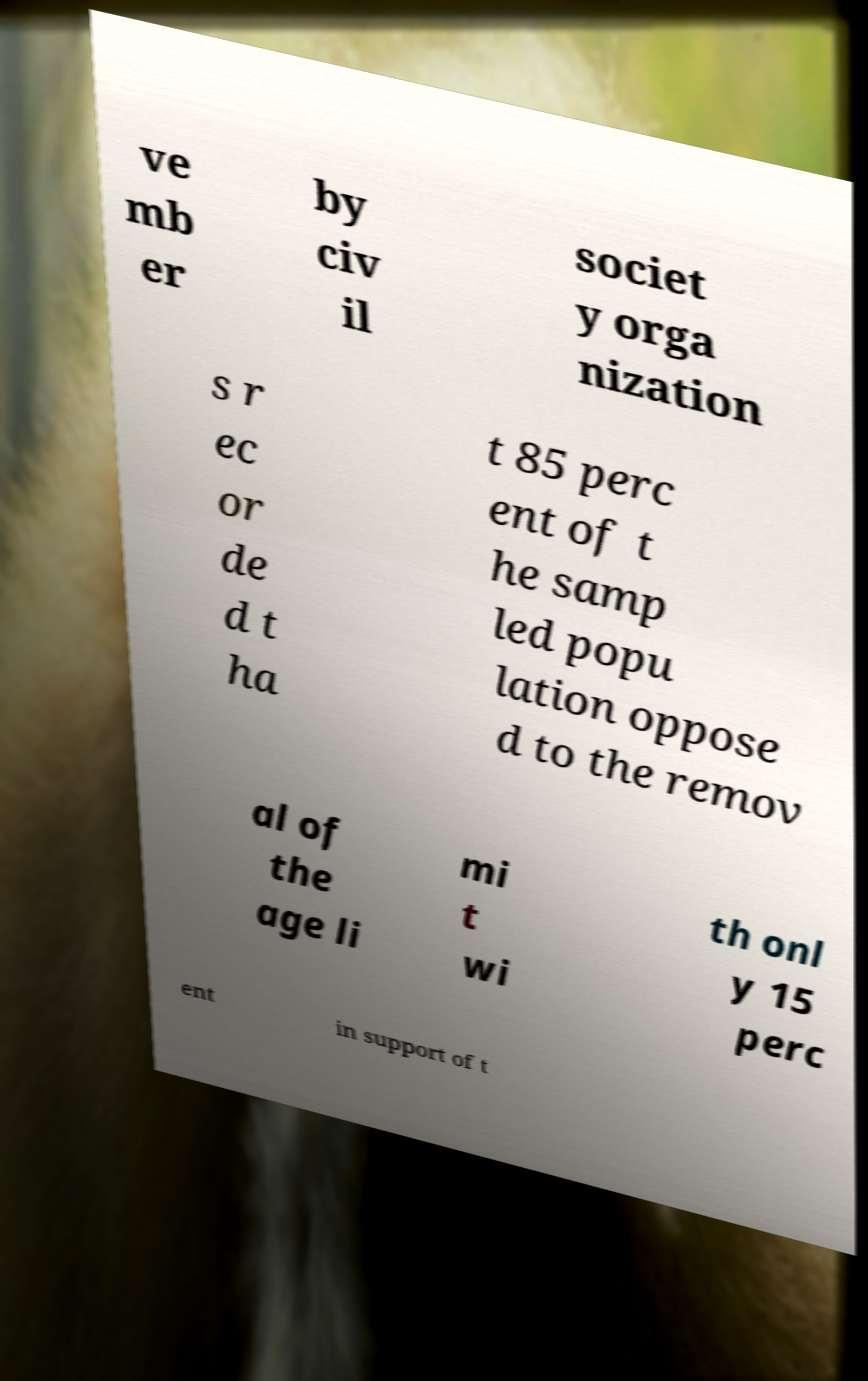I need the written content from this picture converted into text. Can you do that? ve mb er by civ il societ y orga nization s r ec or de d t ha t 85 perc ent of t he samp led popu lation oppose d to the remov al of the age li mi t wi th onl y 15 perc ent in support of t 